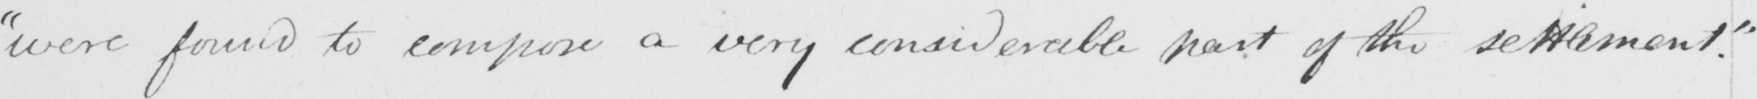What text is written in this handwritten line? " were found to compose a very considerable part of the settlement . " 